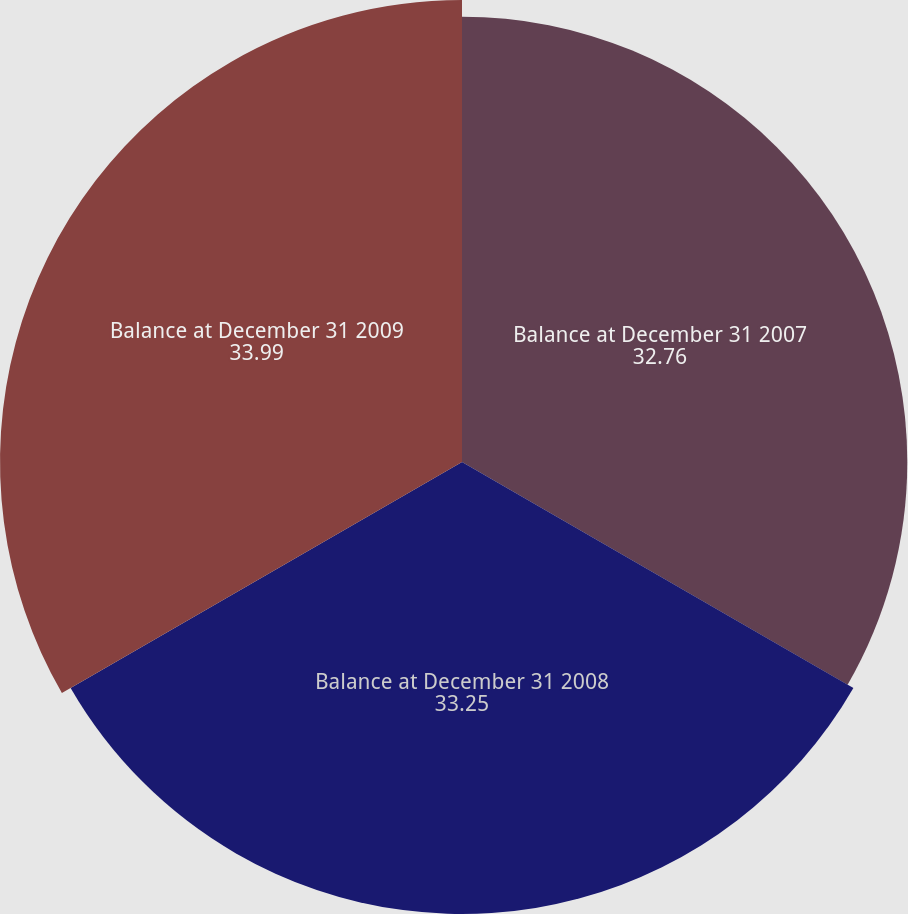<chart> <loc_0><loc_0><loc_500><loc_500><pie_chart><fcel>Balance at December 31 2007<fcel>Balance at December 31 2008<fcel>Balance at December 31 2009<nl><fcel>32.76%<fcel>33.25%<fcel>33.99%<nl></chart> 